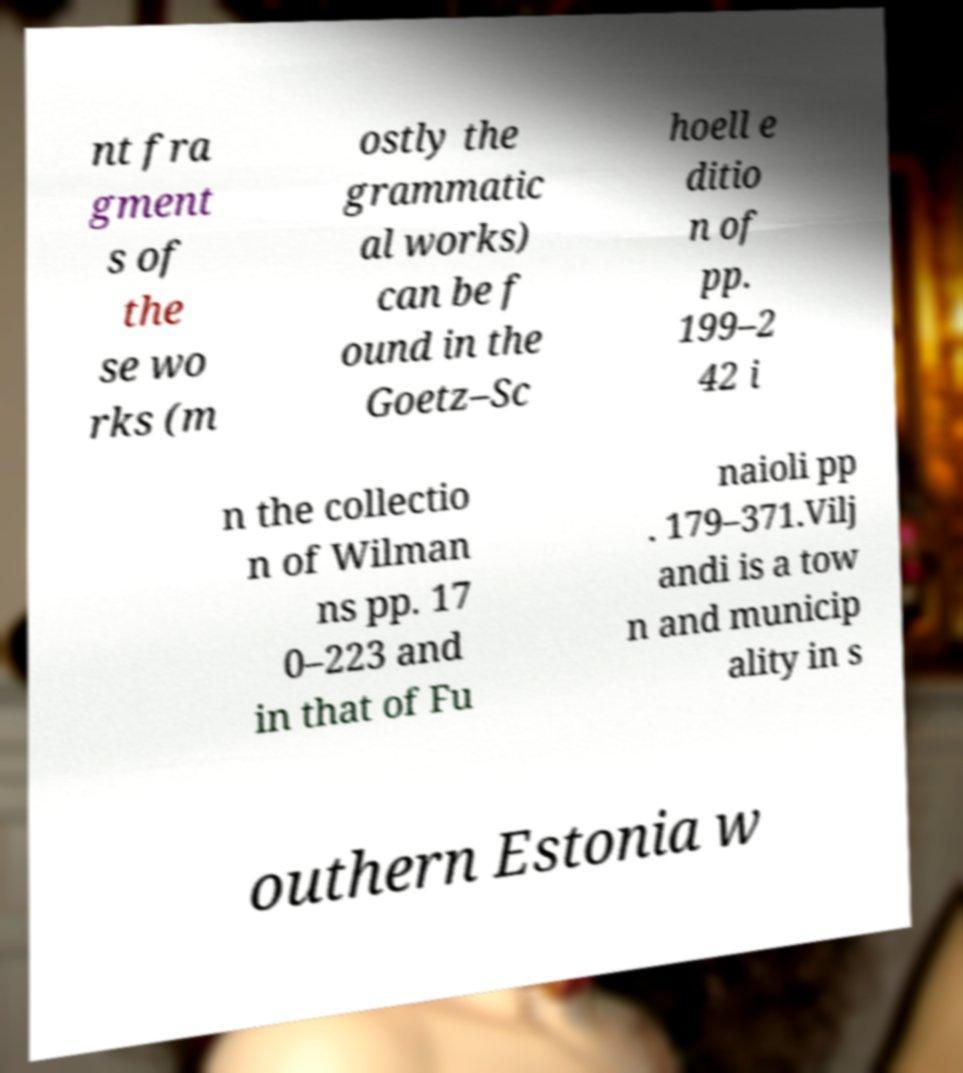For documentation purposes, I need the text within this image transcribed. Could you provide that? nt fra gment s of the se wo rks (m ostly the grammatic al works) can be f ound in the Goetz–Sc hoell e ditio n of pp. 199–2 42 i n the collectio n of Wilman ns pp. 17 0–223 and in that of Fu naioli pp . 179–371.Vilj andi is a tow n and municip ality in s outhern Estonia w 